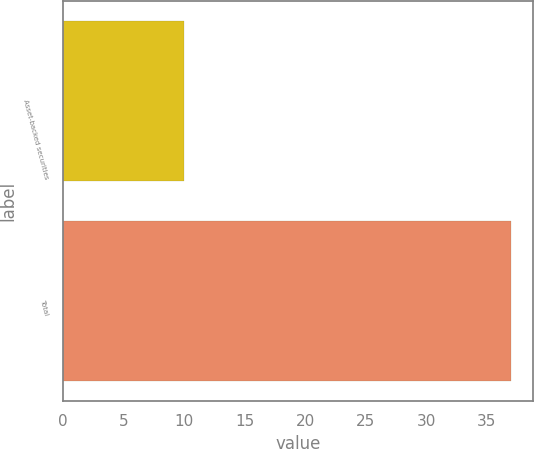<chart> <loc_0><loc_0><loc_500><loc_500><bar_chart><fcel>Asset-backed securities<fcel>Total<nl><fcel>10<fcel>37<nl></chart> 